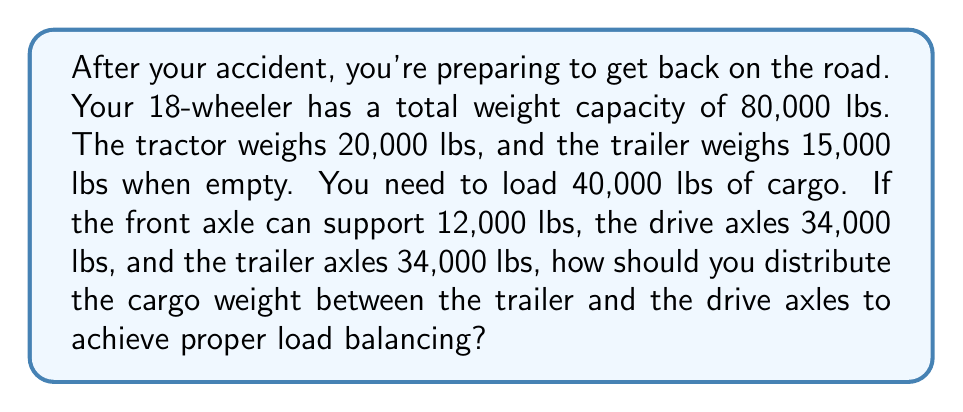Provide a solution to this math problem. Let's approach this step-by-step:

1) First, let's calculate the total weight of the truck with cargo:
   $$ 20,000 + 15,000 + 40,000 = 75,000 \text{ lbs} $$

2) Now, we need to distribute this weight across the axles. Let $x$ be the weight on the drive axles and $y$ be the weight on the trailer axles.

3) We know the front axle will support 12,000 lbs, so:
   $$ x + y = 75,000 - 12,000 = 63,000 \text{ lbs} $$

4) We also know that neither the drive axles nor the trailer axles can exceed 34,000 lbs:
   $$ x \leq 34,000 \text{ and } y \leq 34,000 $$

5) To achieve proper load balancing, we want to distribute the weight as evenly as possible between the drive axles and trailer axles. Mathematically, this means:
   $$ x = y = 63,000 \div 2 = 31,500 \text{ lbs} $$

6) This solution satisfies our constraints as it's below the 34,000 lbs limit for each axle group.

7) To find how much cargo weight should be on each axle group:
   - For drive axles: $31,500 - 20,000 = 11,500 \text{ lbs of cargo}$
   - For trailer axles: $31,500 - 15,000 = 16,500 \text{ lbs of cargo}$

Therefore, to achieve proper load balancing, you should place 11,500 lbs of cargo over the drive axles and 16,500 lbs of cargo in the trailer.
Answer: 11,500 lbs on drive axles, 16,500 lbs on trailer axles 